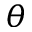<formula> <loc_0><loc_0><loc_500><loc_500>\theta</formula> 